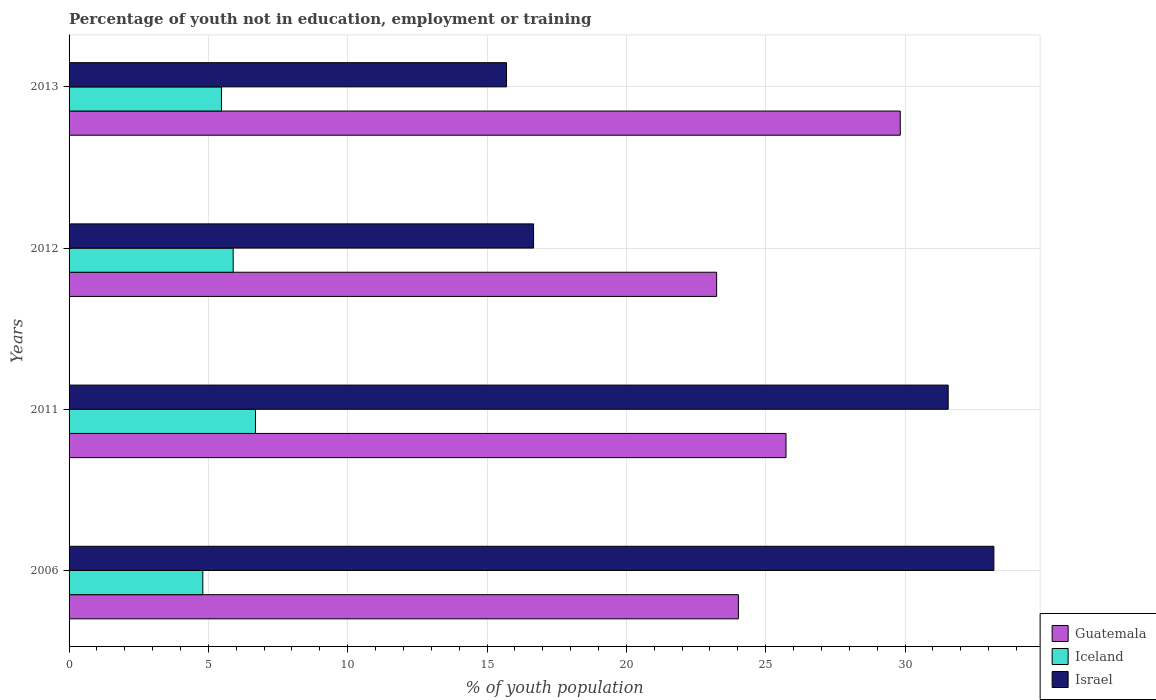How many groups of bars are there?
Offer a very short reply. 4. Are the number of bars per tick equal to the number of legend labels?
Give a very brief answer. Yes. How many bars are there on the 4th tick from the top?
Make the answer very short. 3. What is the label of the 4th group of bars from the top?
Give a very brief answer. 2006. What is the percentage of unemployed youth population in in Israel in 2006?
Your answer should be compact. 33.19. Across all years, what is the maximum percentage of unemployed youth population in in Israel?
Your response must be concise. 33.19. Across all years, what is the minimum percentage of unemployed youth population in in Guatemala?
Provide a succinct answer. 23.24. In which year was the percentage of unemployed youth population in in Israel maximum?
Make the answer very short. 2006. In which year was the percentage of unemployed youth population in in Guatemala minimum?
Offer a terse response. 2012. What is the total percentage of unemployed youth population in in Israel in the graph?
Your response must be concise. 97.11. What is the difference between the percentage of unemployed youth population in in Iceland in 2012 and that in 2013?
Your answer should be very brief. 0.42. What is the difference between the percentage of unemployed youth population in in Iceland in 2006 and the percentage of unemployed youth population in in Israel in 2013?
Keep it short and to the point. -10.9. What is the average percentage of unemployed youth population in in Israel per year?
Offer a very short reply. 24.28. In the year 2006, what is the difference between the percentage of unemployed youth population in in Israel and percentage of unemployed youth population in in Guatemala?
Your response must be concise. 9.17. In how many years, is the percentage of unemployed youth population in in Iceland greater than 22 %?
Offer a terse response. 0. What is the ratio of the percentage of unemployed youth population in in Guatemala in 2006 to that in 2012?
Provide a succinct answer. 1.03. Is the percentage of unemployed youth population in in Guatemala in 2006 less than that in 2013?
Your answer should be compact. Yes. Is the difference between the percentage of unemployed youth population in in Israel in 2006 and 2011 greater than the difference between the percentage of unemployed youth population in in Guatemala in 2006 and 2011?
Your answer should be compact. Yes. What is the difference between the highest and the second highest percentage of unemployed youth population in in Israel?
Your answer should be very brief. 1.64. What is the difference between the highest and the lowest percentage of unemployed youth population in in Israel?
Your response must be concise. 17.49. Is the sum of the percentage of unemployed youth population in in Guatemala in 2006 and 2011 greater than the maximum percentage of unemployed youth population in in Israel across all years?
Provide a short and direct response. Yes. What does the 3rd bar from the top in 2006 represents?
Your answer should be compact. Guatemala. What does the 2nd bar from the bottom in 2011 represents?
Provide a short and direct response. Iceland. How many years are there in the graph?
Your response must be concise. 4. What is the difference between two consecutive major ticks on the X-axis?
Provide a short and direct response. 5. How are the legend labels stacked?
Your response must be concise. Vertical. What is the title of the graph?
Offer a terse response. Percentage of youth not in education, employment or training. Does "El Salvador" appear as one of the legend labels in the graph?
Make the answer very short. No. What is the label or title of the X-axis?
Your answer should be very brief. % of youth population. What is the label or title of the Y-axis?
Make the answer very short. Years. What is the % of youth population of Guatemala in 2006?
Provide a short and direct response. 24.02. What is the % of youth population in Iceland in 2006?
Keep it short and to the point. 4.8. What is the % of youth population of Israel in 2006?
Your answer should be very brief. 33.19. What is the % of youth population in Guatemala in 2011?
Ensure brevity in your answer.  25.73. What is the % of youth population in Iceland in 2011?
Offer a terse response. 6.69. What is the % of youth population in Israel in 2011?
Your answer should be compact. 31.55. What is the % of youth population in Guatemala in 2012?
Provide a short and direct response. 23.24. What is the % of youth population of Iceland in 2012?
Offer a terse response. 5.89. What is the % of youth population in Israel in 2012?
Offer a terse response. 16.67. What is the % of youth population of Guatemala in 2013?
Provide a succinct answer. 29.83. What is the % of youth population of Iceland in 2013?
Offer a very short reply. 5.47. What is the % of youth population of Israel in 2013?
Your answer should be compact. 15.7. Across all years, what is the maximum % of youth population in Guatemala?
Offer a very short reply. 29.83. Across all years, what is the maximum % of youth population of Iceland?
Provide a succinct answer. 6.69. Across all years, what is the maximum % of youth population in Israel?
Keep it short and to the point. 33.19. Across all years, what is the minimum % of youth population in Guatemala?
Offer a terse response. 23.24. Across all years, what is the minimum % of youth population in Iceland?
Give a very brief answer. 4.8. Across all years, what is the minimum % of youth population in Israel?
Offer a very short reply. 15.7. What is the total % of youth population in Guatemala in the graph?
Offer a very short reply. 102.82. What is the total % of youth population of Iceland in the graph?
Offer a very short reply. 22.85. What is the total % of youth population in Israel in the graph?
Give a very brief answer. 97.11. What is the difference between the % of youth population of Guatemala in 2006 and that in 2011?
Offer a terse response. -1.71. What is the difference between the % of youth population of Iceland in 2006 and that in 2011?
Your answer should be very brief. -1.89. What is the difference between the % of youth population in Israel in 2006 and that in 2011?
Keep it short and to the point. 1.64. What is the difference between the % of youth population in Guatemala in 2006 and that in 2012?
Give a very brief answer. 0.78. What is the difference between the % of youth population of Iceland in 2006 and that in 2012?
Offer a terse response. -1.09. What is the difference between the % of youth population of Israel in 2006 and that in 2012?
Offer a terse response. 16.52. What is the difference between the % of youth population in Guatemala in 2006 and that in 2013?
Your answer should be very brief. -5.81. What is the difference between the % of youth population in Iceland in 2006 and that in 2013?
Keep it short and to the point. -0.67. What is the difference between the % of youth population of Israel in 2006 and that in 2013?
Provide a succinct answer. 17.49. What is the difference between the % of youth population in Guatemala in 2011 and that in 2012?
Your answer should be very brief. 2.49. What is the difference between the % of youth population of Israel in 2011 and that in 2012?
Give a very brief answer. 14.88. What is the difference between the % of youth population of Guatemala in 2011 and that in 2013?
Your answer should be compact. -4.1. What is the difference between the % of youth population of Iceland in 2011 and that in 2013?
Give a very brief answer. 1.22. What is the difference between the % of youth population in Israel in 2011 and that in 2013?
Provide a succinct answer. 15.85. What is the difference between the % of youth population of Guatemala in 2012 and that in 2013?
Keep it short and to the point. -6.59. What is the difference between the % of youth population in Iceland in 2012 and that in 2013?
Your response must be concise. 0.42. What is the difference between the % of youth population of Israel in 2012 and that in 2013?
Offer a very short reply. 0.97. What is the difference between the % of youth population of Guatemala in 2006 and the % of youth population of Iceland in 2011?
Provide a succinct answer. 17.33. What is the difference between the % of youth population in Guatemala in 2006 and the % of youth population in Israel in 2011?
Make the answer very short. -7.53. What is the difference between the % of youth population of Iceland in 2006 and the % of youth population of Israel in 2011?
Your answer should be very brief. -26.75. What is the difference between the % of youth population in Guatemala in 2006 and the % of youth population in Iceland in 2012?
Your answer should be compact. 18.13. What is the difference between the % of youth population of Guatemala in 2006 and the % of youth population of Israel in 2012?
Your answer should be compact. 7.35. What is the difference between the % of youth population in Iceland in 2006 and the % of youth population in Israel in 2012?
Offer a very short reply. -11.87. What is the difference between the % of youth population in Guatemala in 2006 and the % of youth population in Iceland in 2013?
Make the answer very short. 18.55. What is the difference between the % of youth population in Guatemala in 2006 and the % of youth population in Israel in 2013?
Your answer should be very brief. 8.32. What is the difference between the % of youth population of Iceland in 2006 and the % of youth population of Israel in 2013?
Your answer should be very brief. -10.9. What is the difference between the % of youth population of Guatemala in 2011 and the % of youth population of Iceland in 2012?
Your response must be concise. 19.84. What is the difference between the % of youth population of Guatemala in 2011 and the % of youth population of Israel in 2012?
Offer a very short reply. 9.06. What is the difference between the % of youth population in Iceland in 2011 and the % of youth population in Israel in 2012?
Keep it short and to the point. -9.98. What is the difference between the % of youth population of Guatemala in 2011 and the % of youth population of Iceland in 2013?
Offer a terse response. 20.26. What is the difference between the % of youth population in Guatemala in 2011 and the % of youth population in Israel in 2013?
Your answer should be very brief. 10.03. What is the difference between the % of youth population of Iceland in 2011 and the % of youth population of Israel in 2013?
Offer a very short reply. -9.01. What is the difference between the % of youth population of Guatemala in 2012 and the % of youth population of Iceland in 2013?
Your response must be concise. 17.77. What is the difference between the % of youth population in Guatemala in 2012 and the % of youth population in Israel in 2013?
Ensure brevity in your answer.  7.54. What is the difference between the % of youth population in Iceland in 2012 and the % of youth population in Israel in 2013?
Your answer should be very brief. -9.81. What is the average % of youth population in Guatemala per year?
Give a very brief answer. 25.7. What is the average % of youth population in Iceland per year?
Ensure brevity in your answer.  5.71. What is the average % of youth population of Israel per year?
Offer a terse response. 24.28. In the year 2006, what is the difference between the % of youth population in Guatemala and % of youth population in Iceland?
Keep it short and to the point. 19.22. In the year 2006, what is the difference between the % of youth population in Guatemala and % of youth population in Israel?
Keep it short and to the point. -9.17. In the year 2006, what is the difference between the % of youth population of Iceland and % of youth population of Israel?
Give a very brief answer. -28.39. In the year 2011, what is the difference between the % of youth population in Guatemala and % of youth population in Iceland?
Your response must be concise. 19.04. In the year 2011, what is the difference between the % of youth population in Guatemala and % of youth population in Israel?
Your answer should be very brief. -5.82. In the year 2011, what is the difference between the % of youth population of Iceland and % of youth population of Israel?
Make the answer very short. -24.86. In the year 2012, what is the difference between the % of youth population of Guatemala and % of youth population of Iceland?
Give a very brief answer. 17.35. In the year 2012, what is the difference between the % of youth population of Guatemala and % of youth population of Israel?
Your answer should be very brief. 6.57. In the year 2012, what is the difference between the % of youth population in Iceland and % of youth population in Israel?
Keep it short and to the point. -10.78. In the year 2013, what is the difference between the % of youth population in Guatemala and % of youth population in Iceland?
Your answer should be very brief. 24.36. In the year 2013, what is the difference between the % of youth population of Guatemala and % of youth population of Israel?
Your response must be concise. 14.13. In the year 2013, what is the difference between the % of youth population of Iceland and % of youth population of Israel?
Give a very brief answer. -10.23. What is the ratio of the % of youth population of Guatemala in 2006 to that in 2011?
Ensure brevity in your answer.  0.93. What is the ratio of the % of youth population in Iceland in 2006 to that in 2011?
Provide a short and direct response. 0.72. What is the ratio of the % of youth population in Israel in 2006 to that in 2011?
Provide a short and direct response. 1.05. What is the ratio of the % of youth population in Guatemala in 2006 to that in 2012?
Keep it short and to the point. 1.03. What is the ratio of the % of youth population in Iceland in 2006 to that in 2012?
Your answer should be very brief. 0.81. What is the ratio of the % of youth population in Israel in 2006 to that in 2012?
Your answer should be very brief. 1.99. What is the ratio of the % of youth population in Guatemala in 2006 to that in 2013?
Your answer should be compact. 0.81. What is the ratio of the % of youth population of Iceland in 2006 to that in 2013?
Give a very brief answer. 0.88. What is the ratio of the % of youth population of Israel in 2006 to that in 2013?
Your answer should be very brief. 2.11. What is the ratio of the % of youth population in Guatemala in 2011 to that in 2012?
Offer a very short reply. 1.11. What is the ratio of the % of youth population of Iceland in 2011 to that in 2012?
Your answer should be very brief. 1.14. What is the ratio of the % of youth population in Israel in 2011 to that in 2012?
Ensure brevity in your answer.  1.89. What is the ratio of the % of youth population of Guatemala in 2011 to that in 2013?
Your answer should be compact. 0.86. What is the ratio of the % of youth population in Iceland in 2011 to that in 2013?
Provide a succinct answer. 1.22. What is the ratio of the % of youth population in Israel in 2011 to that in 2013?
Provide a short and direct response. 2.01. What is the ratio of the % of youth population of Guatemala in 2012 to that in 2013?
Ensure brevity in your answer.  0.78. What is the ratio of the % of youth population of Iceland in 2012 to that in 2013?
Give a very brief answer. 1.08. What is the ratio of the % of youth population in Israel in 2012 to that in 2013?
Keep it short and to the point. 1.06. What is the difference between the highest and the second highest % of youth population of Iceland?
Keep it short and to the point. 0.8. What is the difference between the highest and the second highest % of youth population in Israel?
Make the answer very short. 1.64. What is the difference between the highest and the lowest % of youth population of Guatemala?
Your response must be concise. 6.59. What is the difference between the highest and the lowest % of youth population in Iceland?
Your answer should be compact. 1.89. What is the difference between the highest and the lowest % of youth population in Israel?
Your answer should be very brief. 17.49. 